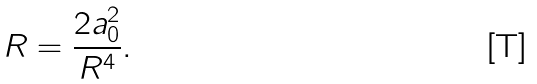Convert formula to latex. <formula><loc_0><loc_0><loc_500><loc_500>R = \frac { 2 a _ { 0 } ^ { 2 } } { R ^ { 4 } } .</formula> 